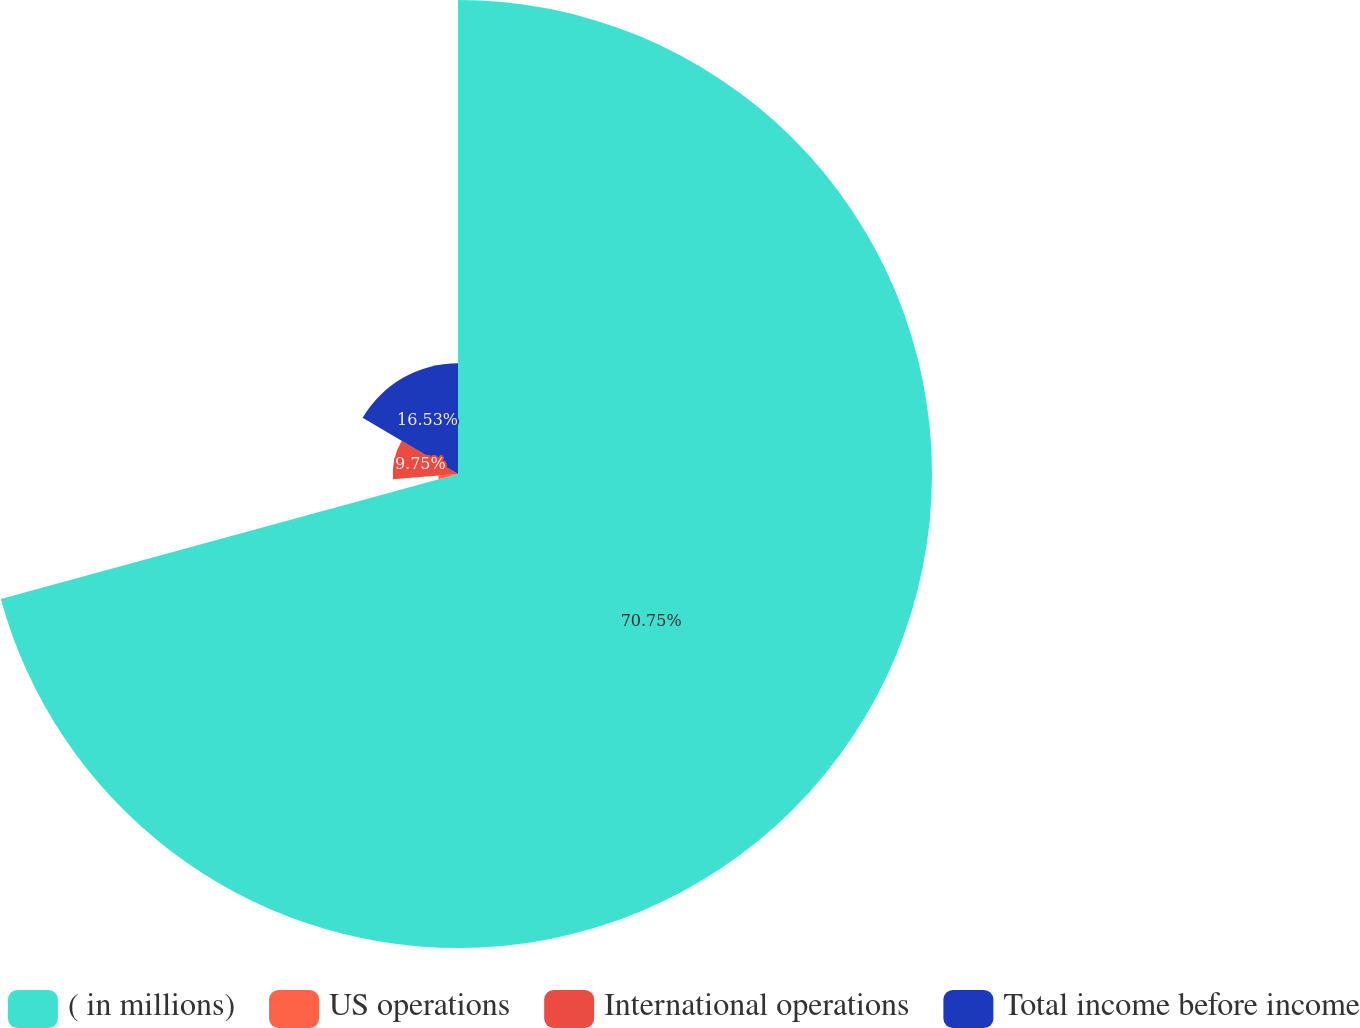Convert chart to OTSL. <chart><loc_0><loc_0><loc_500><loc_500><pie_chart><fcel>( in millions)<fcel>US operations<fcel>International operations<fcel>Total income before income<nl><fcel>70.76%<fcel>2.97%<fcel>9.75%<fcel>16.53%<nl></chart> 